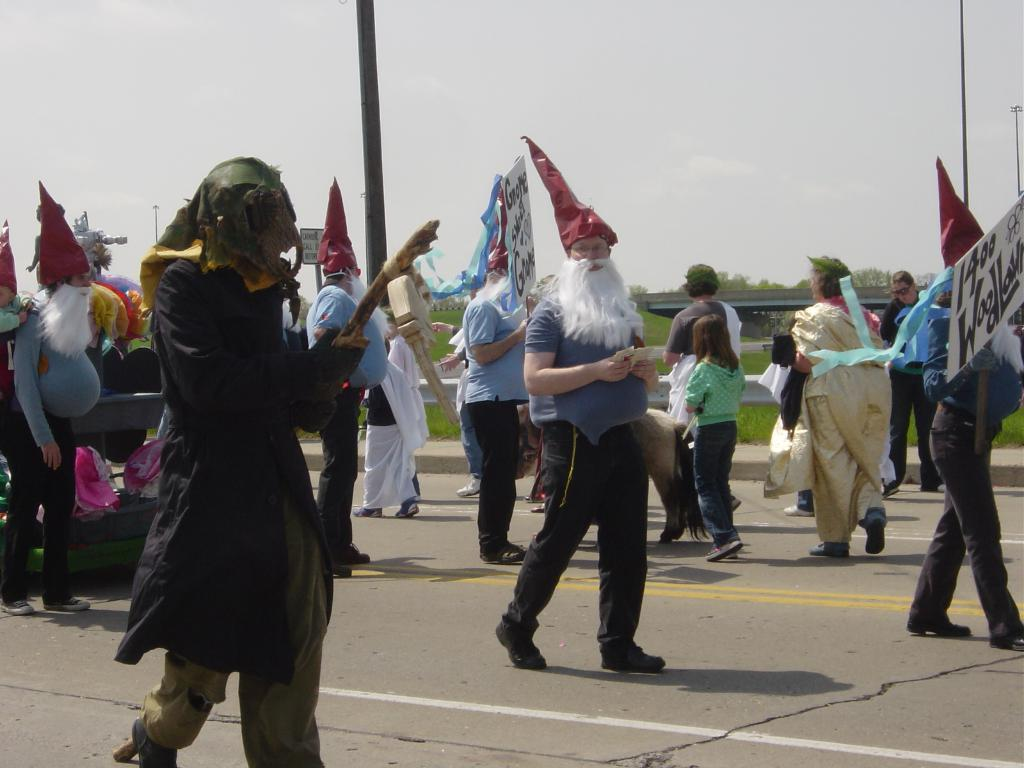What are the people in the image doing? The people in the image are walking on the road. What are the people wearing on their faces? The people are wearing masks. What additional clothing items can be seen on some people? Some people are wearing capes and helmets. Can you describe the person on the right side of the image? There is a person holding a placard on the right side of the image. What can be seen in the background of the image? There is a pillar, the sky, a grass lawn, and trees in the background. Can you tell me how many ocean waves are visible in the image? There are no ocean waves present in the image. What type of volcano can be seen erupting in the background? There is no volcano present in the image. 